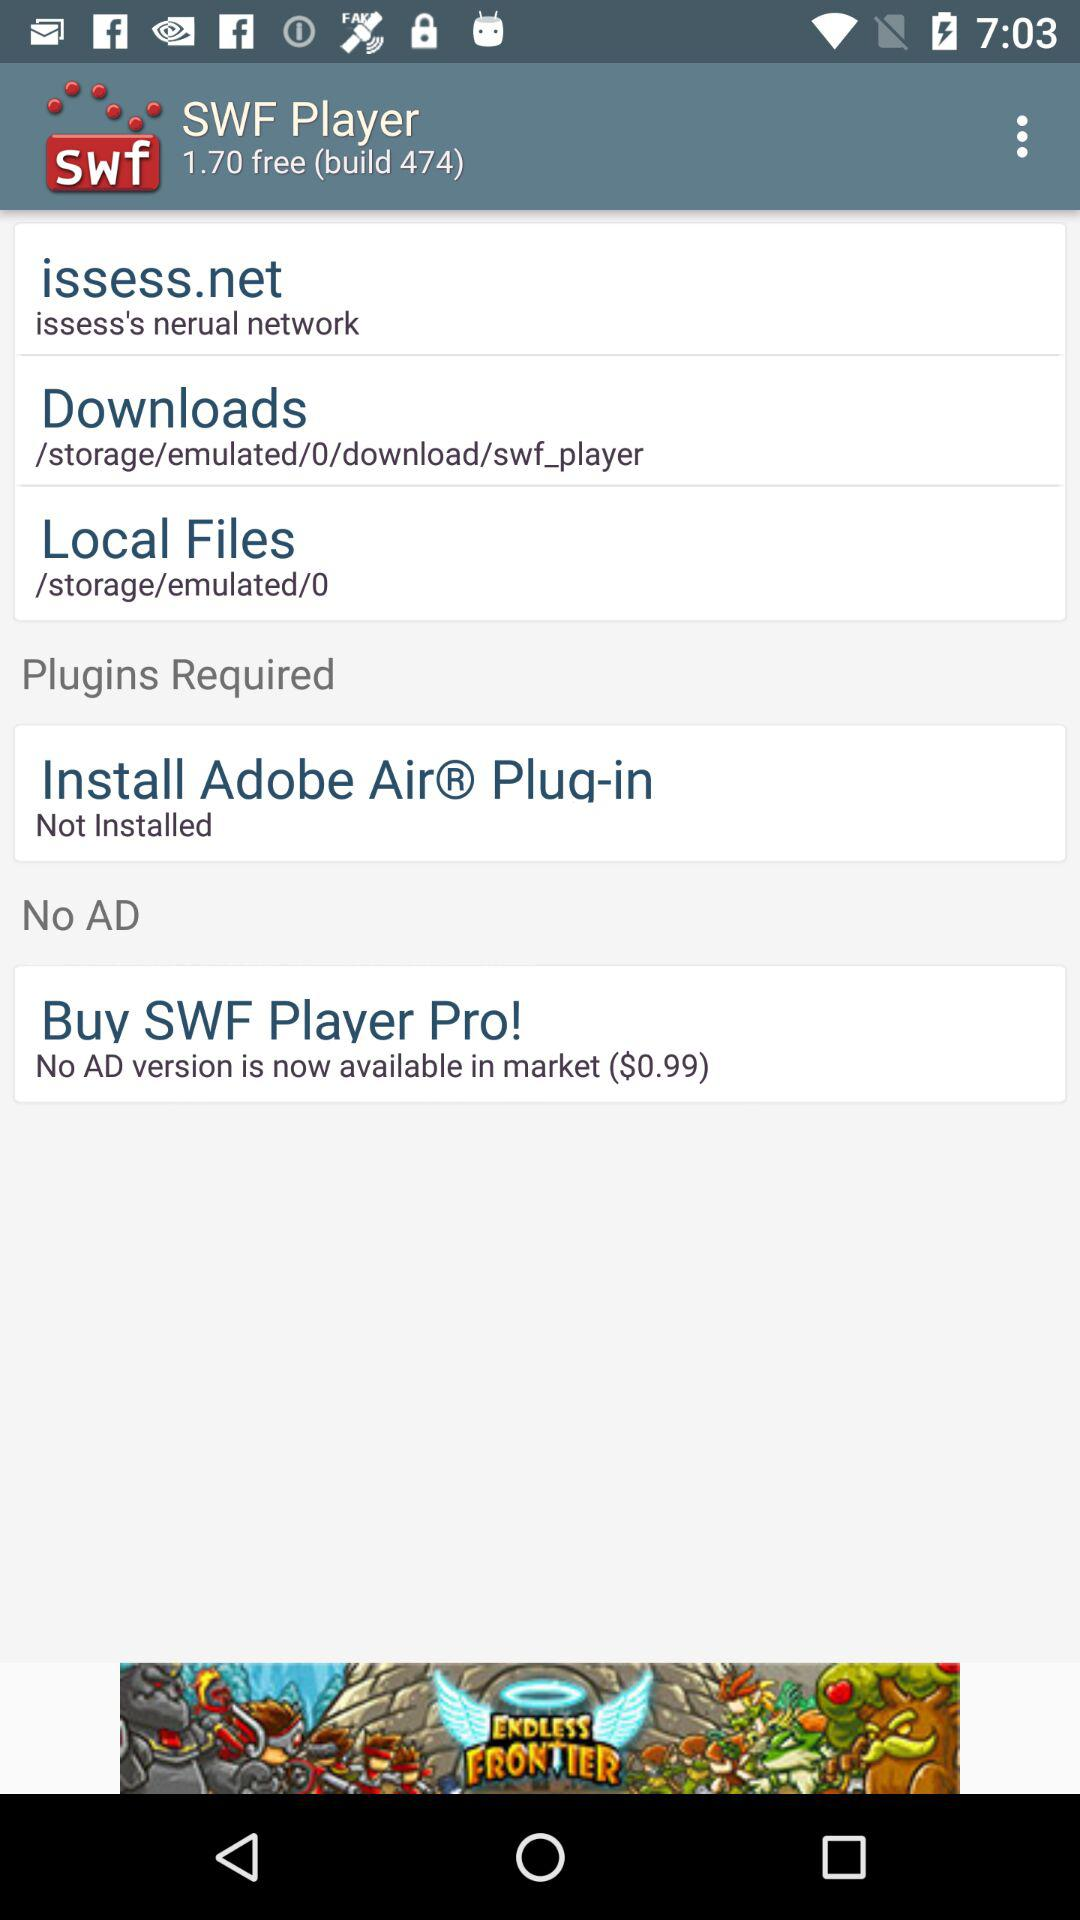What is the version of the application? The version of the application is 1.70 free (build 474). 